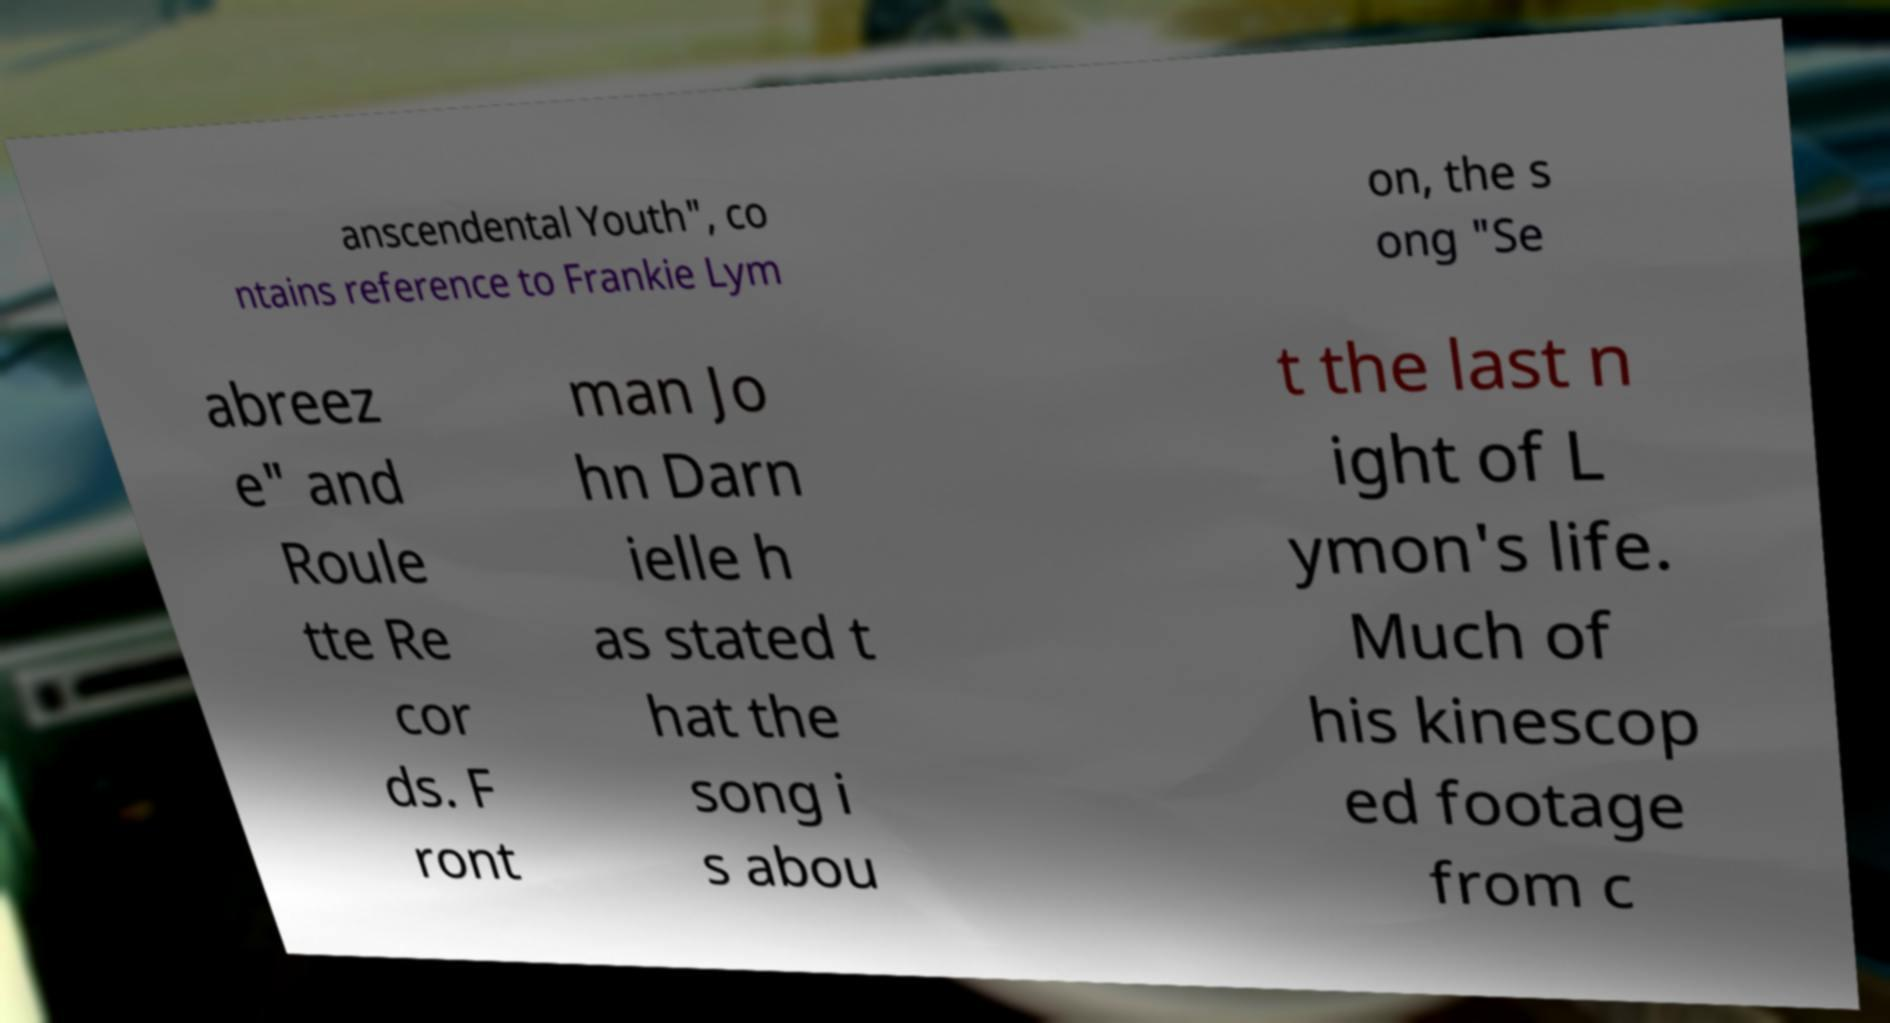There's text embedded in this image that I need extracted. Can you transcribe it verbatim? anscendental Youth", co ntains reference to Frankie Lym on, the s ong "Se abreez e" and Roule tte Re cor ds. F ront man Jo hn Darn ielle h as stated t hat the song i s abou t the last n ight of L ymon's life. Much of his kinescop ed footage from c 